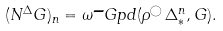<formula> <loc_0><loc_0><loc_500><loc_500>( N ^ { \Delta } G ) _ { n } = \omega \text {-} G p d ( \rho ^ { \bigcirc } \, \Delta ^ { n } _ { * } , G ) .</formula> 